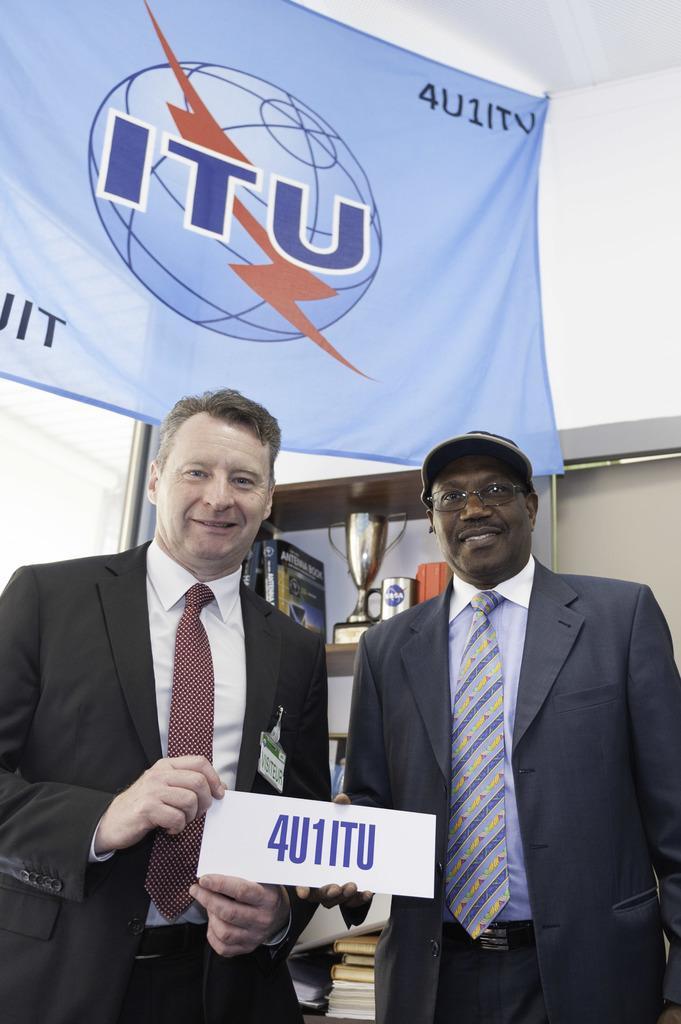Could you give a brief overview of what you see in this image? In this picture we can see two man are standing and holding a card and on it we can see a 4U1ITU and they are in blazers, ties and shirts and behind them we can see a rack with some books, prize cup and to the ceiling we can see a banner with a symbol ITU. 